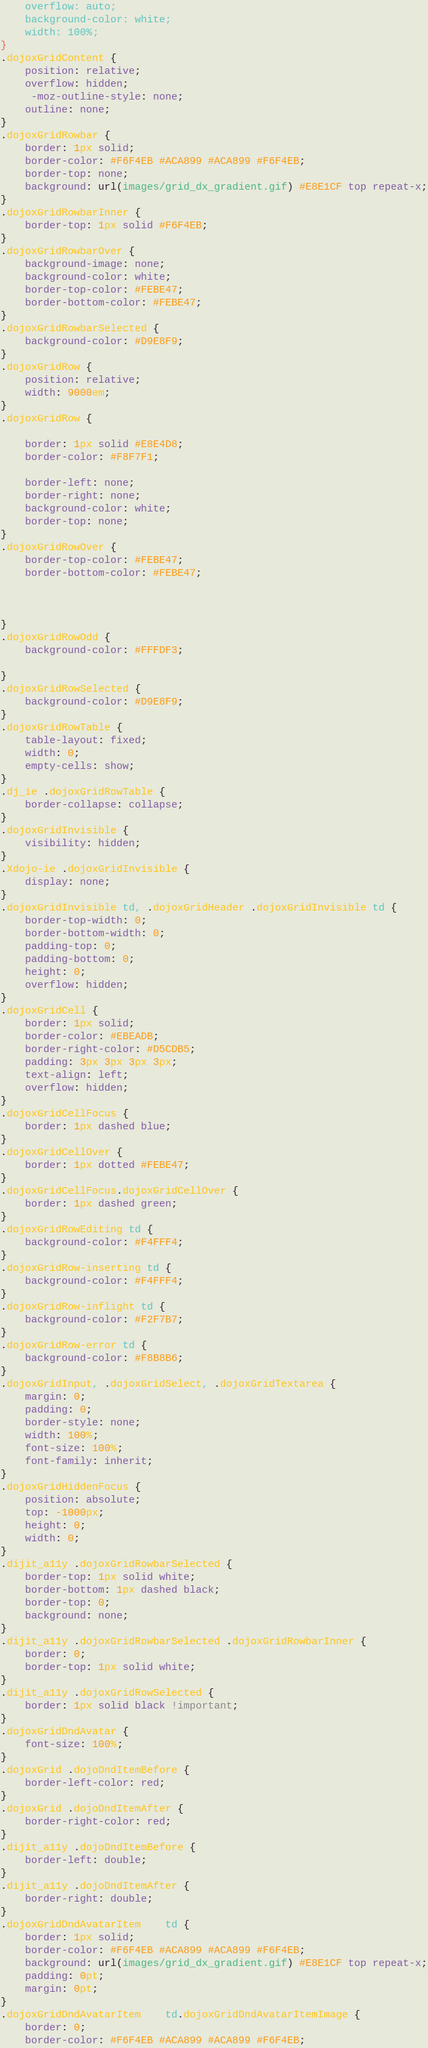Convert code to text. <code><loc_0><loc_0><loc_500><loc_500><_CSS_>	overflow: auto;
	background-color: white;
	width: 100%;
}
.dojoxGridContent {
	position: relative;
	overflow: hidden;
	 -moz-outline-style: none;
	outline: none;
}
.dojoxGridRowbar { 
	border: 1px solid;
	border-color: #F6F4EB #ACA899 #ACA899 #F6F4EB;
	border-top: none;
	background: url(images/grid_dx_gradient.gif) #E8E1CF top repeat-x;
}
.dojoxGridRowbarInner {
	border-top: 1px solid #F6F4EB;
}
.dojoxGridRowbarOver {
	background-image: none;
	background-color: white;
	border-top-color: #FEBE47;
	border-bottom-color: #FEBE47;
}
.dojoxGridRowbarSelected {
	background-color: #D9E8F9;
}
.dojoxGridRow {
	position: relative;
	width: 9000em;
}
.dojoxGridRow {
	
	border: 1px solid #E8E4D8;
	border-color: #F8F7F1;
	
	border-left: none;
	border-right: none;
	background-color: white;
	border-top: none;
}
.dojoxGridRowOver {
	border-top-color: #FEBE47;
	border-bottom-color: #FEBE47;
	
	
	
}
.dojoxGridRowOdd {
	background-color: #FFFDF3;
	
}
.dojoxGridRowSelected {
	background-color: #D9E8F9;
}
.dojoxGridRowTable {
	table-layout: fixed;
	width: 0;
	empty-cells: show;
}
.dj_ie .dojoxGridRowTable {
	border-collapse: collapse;
}
.dojoxGridInvisible {
	visibility: hidden;
}		
.Xdojo-ie .dojoxGridInvisible {
	display: none;
}		
.dojoxGridInvisible td, .dojoxGridHeader .dojoxGridInvisible td {
	border-top-width: 0;
	border-bottom-width: 0;
	padding-top: 0;
	padding-bottom: 0;
	height: 0;
	overflow: hidden;
}
.dojoxGridCell {
	border: 1px solid;
	border-color: #EBEADB;
	border-right-color: #D5CDB5;
	padding: 3px 3px 3px 3px;
	text-align: left;
	overflow: hidden;
}
.dojoxGridCellFocus {
	border: 1px dashed blue;
}
.dojoxGridCellOver {
	border: 1px dotted #FEBE47;
}
.dojoxGridCellFocus.dojoxGridCellOver {
	border: 1px dashed green;
}
.dojoxGridRowEditing td {
	background-color: #F4FFF4;
}
.dojoxGridRow-inserting td {
	background-color: #F4FFF4;
}
.dojoxGridRow-inflight td {
	background-color: #F2F7B7;
}
.dojoxGridRow-error td {
	background-color: #F8B8B6;
}
.dojoxGridInput, .dojoxGridSelect, .dojoxGridTextarea {
	margin: 0;
	padding: 0;
	border-style: none;
	width: 100%;
	font-size: 100%;
	font-family: inherit;
}
.dojoxGridHiddenFocus {
	position: absolute;
	top: -1000px;
	height: 0;
	width: 0;
}
.dijit_a11y .dojoxGridRowbarSelected { 
	border-top: 1px solid white;
	border-bottom: 1px dashed black;
	border-top: 0;
	background: none;
}
.dijit_a11y .dojoxGridRowbarSelected .dojoxGridRowbarInner {
	border: 0;
	border-top: 1px solid white;
}
.dijit_a11y .dojoxGridRowSelected {
	border: 1px solid black !important;
}
.dojoxGridDndAvatar {
	font-size: 100%;
}
.dojoxGrid .dojoDndItemBefore {
	border-left-color: red;
}
.dojoxGrid .dojoDndItemAfter {
	border-right-color: red;
}
.dijit_a11y .dojoDndItemBefore {
	border-left: double;
}
.dijit_a11y .dojoDndItemAfter {
	border-right: double;
}
.dojoxGridDndAvatarItem	td {
	border: 1px solid;
	border-color: #F6F4EB #ACA899 #ACA899 #F6F4EB;
	background: url(images/grid_dx_gradient.gif) #E8E1CF top repeat-x;
	padding: 0pt;
	margin: 0pt;
}
.dojoxGridDndAvatarItem	td.dojoxGridDndAvatarItemImage {
	border: 0;
	border-color: #F6F4EB #ACA899 #ACA899 #F6F4EB;</code> 